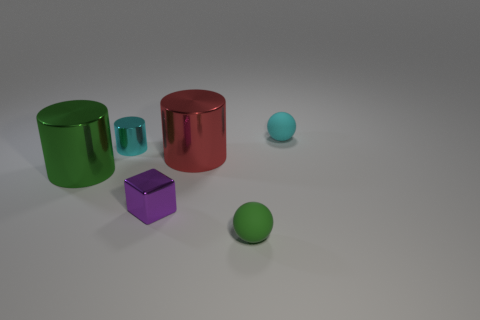Subtract all cyan cylinders. How many cylinders are left? 2 Subtract all cyan cylinders. How many cylinders are left? 2 Add 1 tiny cyan matte things. How many objects exist? 7 Subtract 3 cylinders. How many cylinders are left? 0 Subtract all spheres. How many objects are left? 4 Add 1 yellow rubber spheres. How many yellow rubber spheres exist? 1 Subtract 0 gray cubes. How many objects are left? 6 Subtract all purple spheres. Subtract all purple blocks. How many spheres are left? 2 Subtract all big cyan metallic cylinders. Subtract all purple metallic objects. How many objects are left? 5 Add 3 big green metal cylinders. How many big green metal cylinders are left? 4 